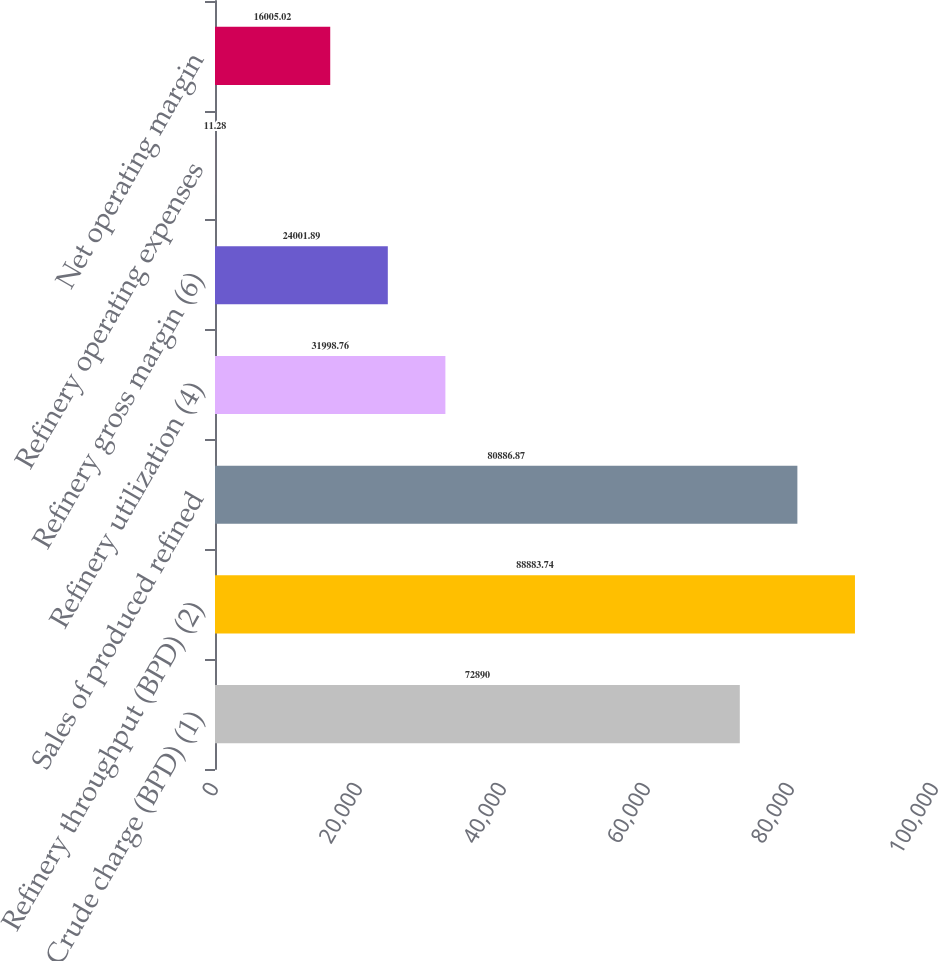Convert chart to OTSL. <chart><loc_0><loc_0><loc_500><loc_500><bar_chart><fcel>Crude charge (BPD) (1)<fcel>Refinery throughput (BPD) (2)<fcel>Sales of produced refined<fcel>Refinery utilization (4)<fcel>Refinery gross margin (6)<fcel>Refinery operating expenses<fcel>Net operating margin<nl><fcel>72890<fcel>88883.7<fcel>80886.9<fcel>31998.8<fcel>24001.9<fcel>11.28<fcel>16005<nl></chart> 